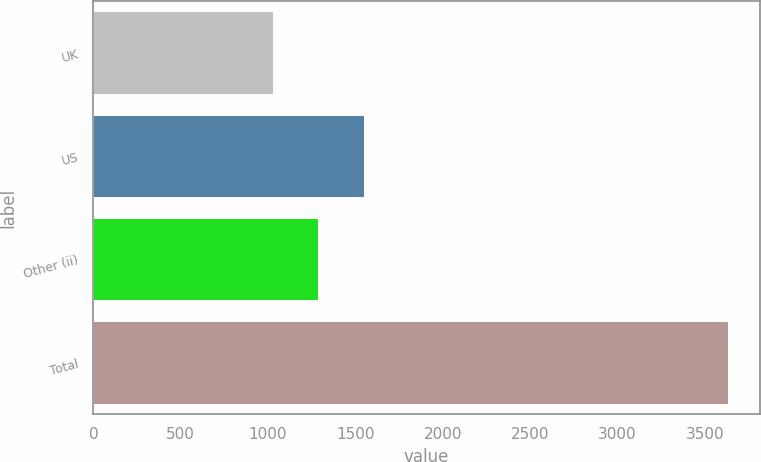Convert chart. <chart><loc_0><loc_0><loc_500><loc_500><bar_chart><fcel>UK<fcel>US<fcel>Other (ii)<fcel>Total<nl><fcel>1026<fcel>1549<fcel>1286.7<fcel>3633<nl></chart> 